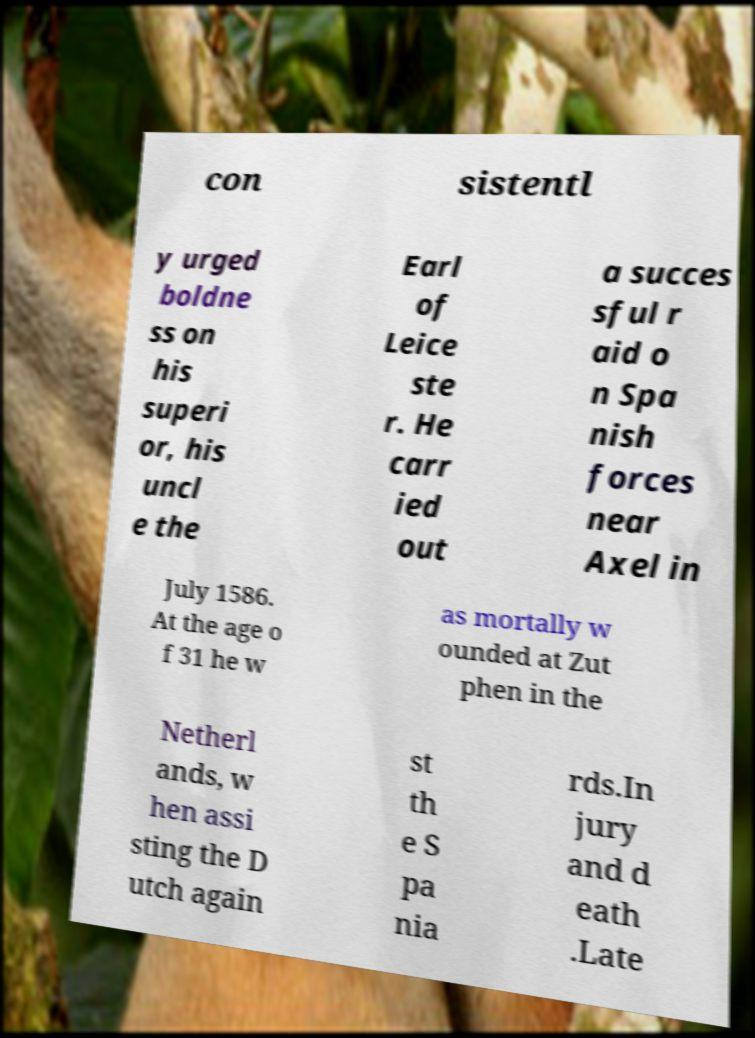I need the written content from this picture converted into text. Can you do that? con sistentl y urged boldne ss on his superi or, his uncl e the Earl of Leice ste r. He carr ied out a succes sful r aid o n Spa nish forces near Axel in July 1586. At the age o f 31 he w as mortally w ounded at Zut phen in the Netherl ands, w hen assi sting the D utch again st th e S pa nia rds.In jury and d eath .Late 